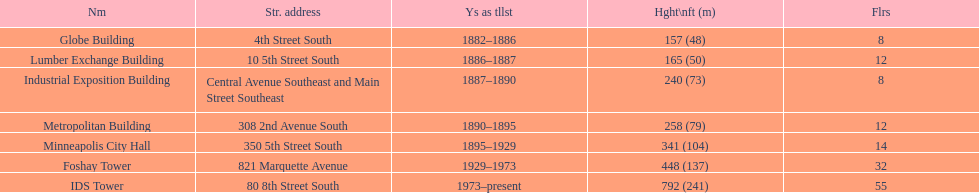Which building has the same number of floors as the lumber exchange building? Metropolitan Building. 